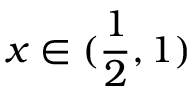Convert formula to latex. <formula><loc_0><loc_0><loc_500><loc_500>x \in ( \frac { 1 } { 2 } , 1 )</formula> 